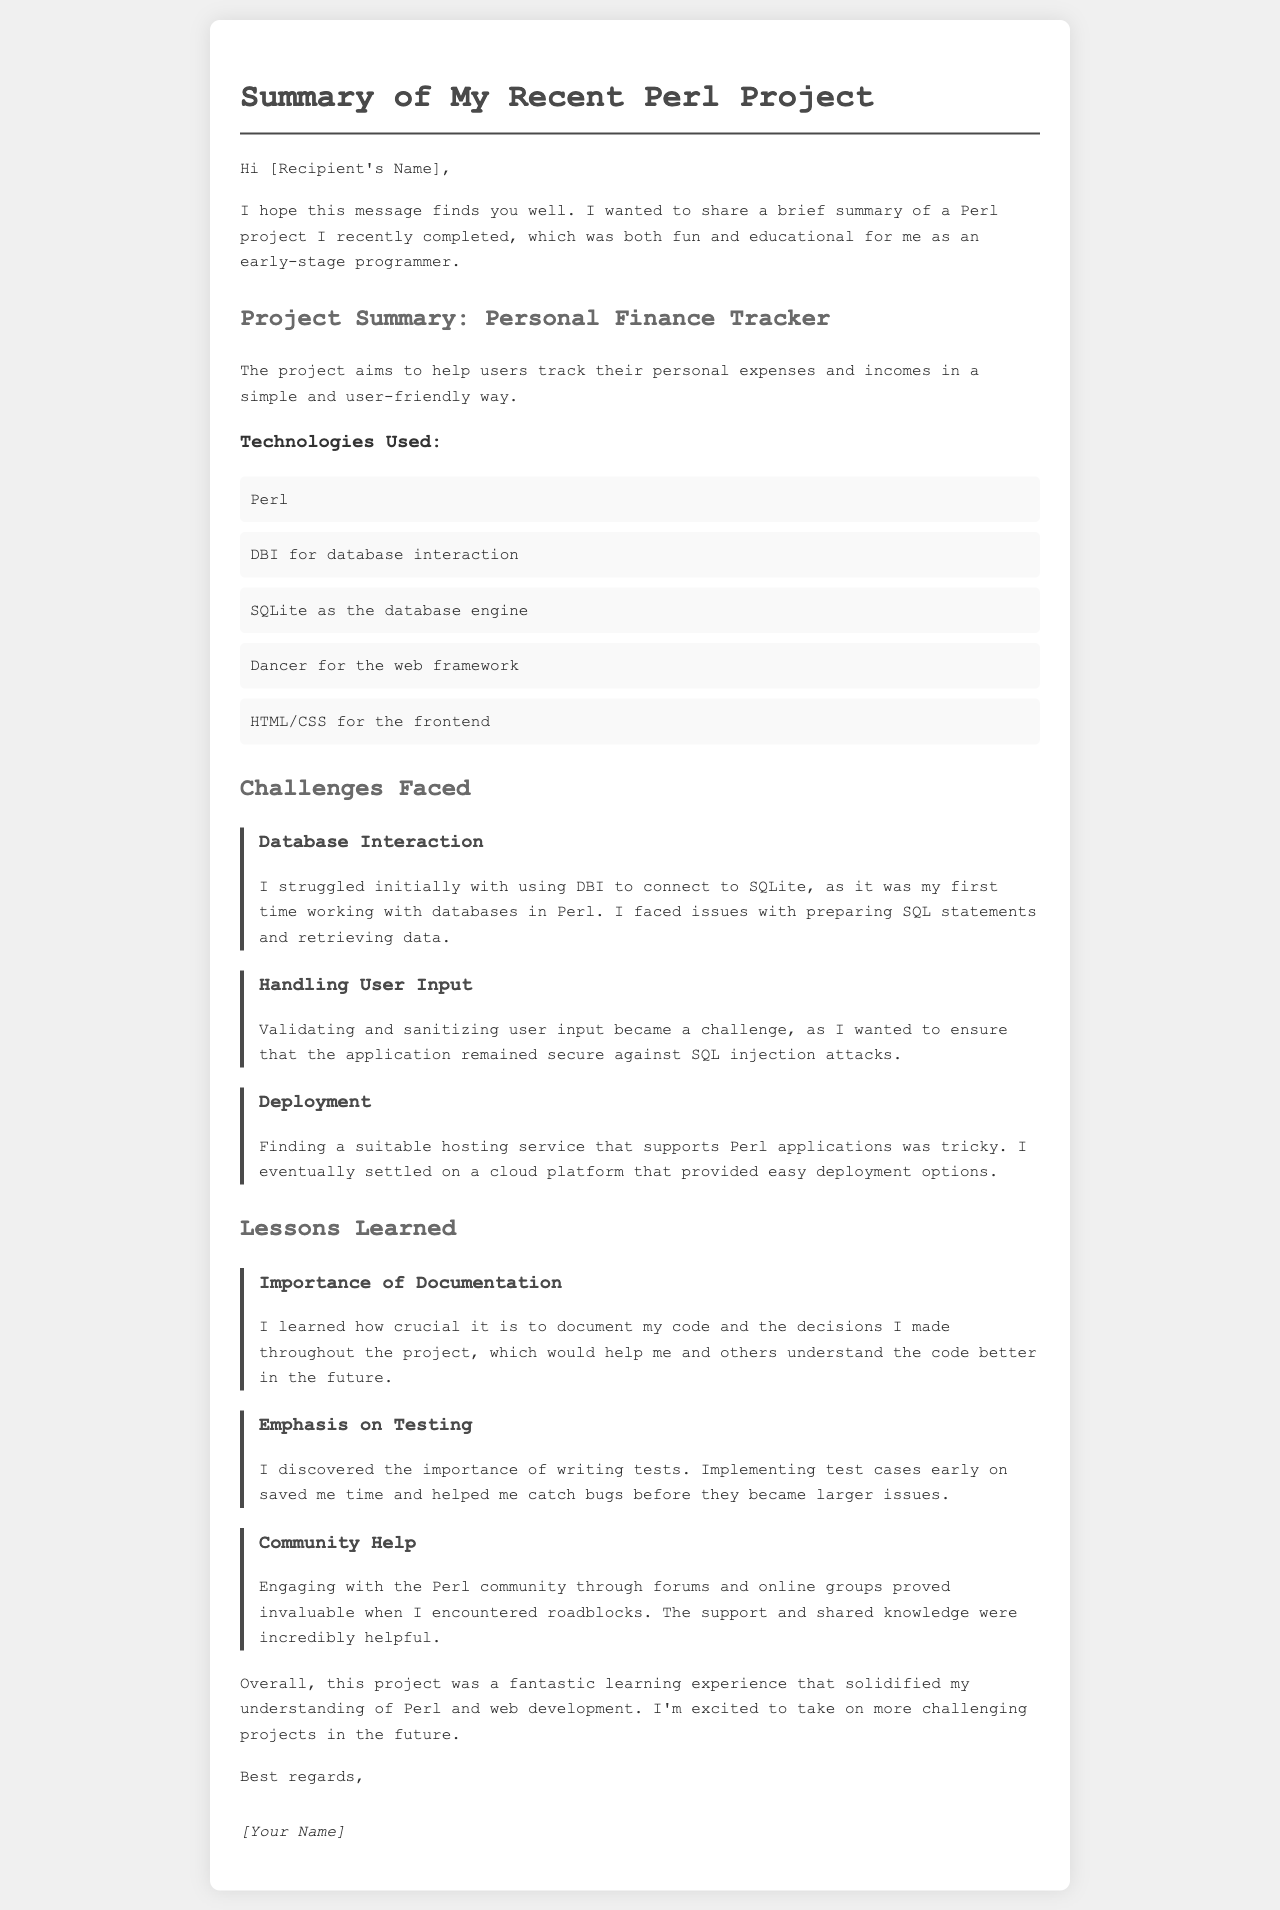what is the title of the project? The title of the project is stated in the section "Project Summary," which describes what the project is about.
Answer: Personal Finance Tracker what technology was used for database interaction? The document lists the technologies used, specifically mentioning the one used for database interaction.
Answer: DBI what is one of the challenges faced during the project? The challenges section lists multiple issues encountered, with "Database Interaction" as one of them.
Answer: Database Interaction how many lessons learned are mentioned? The document details the lessons learned and counts them in the "Lessons Learned" section.
Answer: Three what is emphasized as crucial for project documentation? The lessons learned highlight the significance of documentation in one of the points discussed.
Answer: Importance of Documentation which cloud platform was chosen for deployment? The document mentions a "cloud platform" without specifying the name, indicating the choice was made.
Answer: A cloud platform what did the author learn about community engagement? The lessons learned section mentions engaging with the community and the benefits derived from it.
Answer: Community Help what framework was used for the web development? The project summary lists different technologies, including the one used for the web framework.
Answer: Dancer 